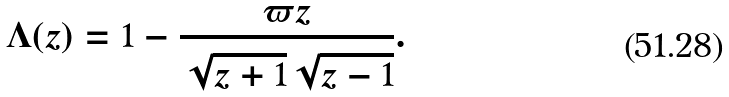Convert formula to latex. <formula><loc_0><loc_0><loc_500><loc_500>\Lambda ( z ) = 1 - \frac { \varpi z } { \sqrt { z + 1 } \sqrt { z - 1 } } .</formula> 